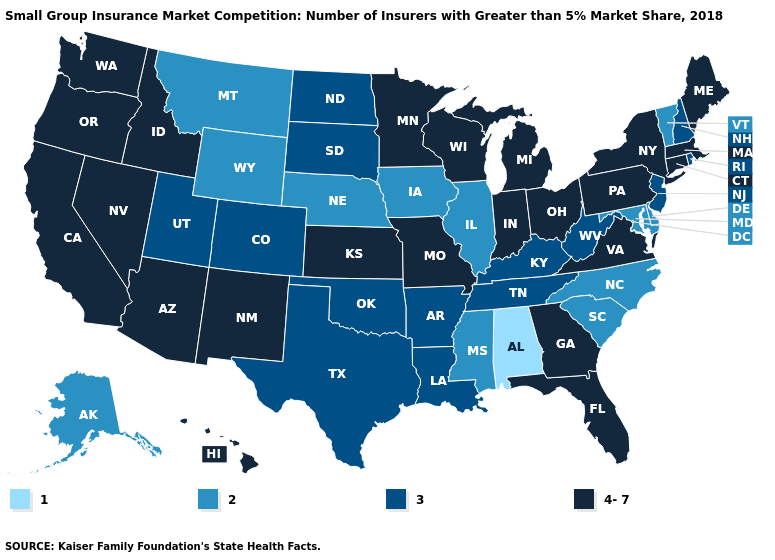What is the value of South Carolina?
Answer briefly. 2. Name the states that have a value in the range 3?
Write a very short answer. Arkansas, Colorado, Kentucky, Louisiana, New Hampshire, New Jersey, North Dakota, Oklahoma, Rhode Island, South Dakota, Tennessee, Texas, Utah, West Virginia. Name the states that have a value in the range 3?
Answer briefly. Arkansas, Colorado, Kentucky, Louisiana, New Hampshire, New Jersey, North Dakota, Oklahoma, Rhode Island, South Dakota, Tennessee, Texas, Utah, West Virginia. Name the states that have a value in the range 2?
Concise answer only. Alaska, Delaware, Illinois, Iowa, Maryland, Mississippi, Montana, Nebraska, North Carolina, South Carolina, Vermont, Wyoming. What is the value of Wyoming?
Answer briefly. 2. Does Alabama have a lower value than Alaska?
Keep it brief. Yes. What is the value of New Mexico?
Keep it brief. 4-7. Does Virginia have the highest value in the South?
Give a very brief answer. Yes. Does Connecticut have the highest value in the USA?
Keep it brief. Yes. What is the value of Oklahoma?
Short answer required. 3. What is the highest value in states that border Wyoming?
Keep it brief. 4-7. What is the lowest value in the USA?
Write a very short answer. 1. Name the states that have a value in the range 4-7?
Concise answer only. Arizona, California, Connecticut, Florida, Georgia, Hawaii, Idaho, Indiana, Kansas, Maine, Massachusetts, Michigan, Minnesota, Missouri, Nevada, New Mexico, New York, Ohio, Oregon, Pennsylvania, Virginia, Washington, Wisconsin. Does Alabama have the lowest value in the USA?
Keep it brief. Yes. What is the value of Louisiana?
Be succinct. 3. 